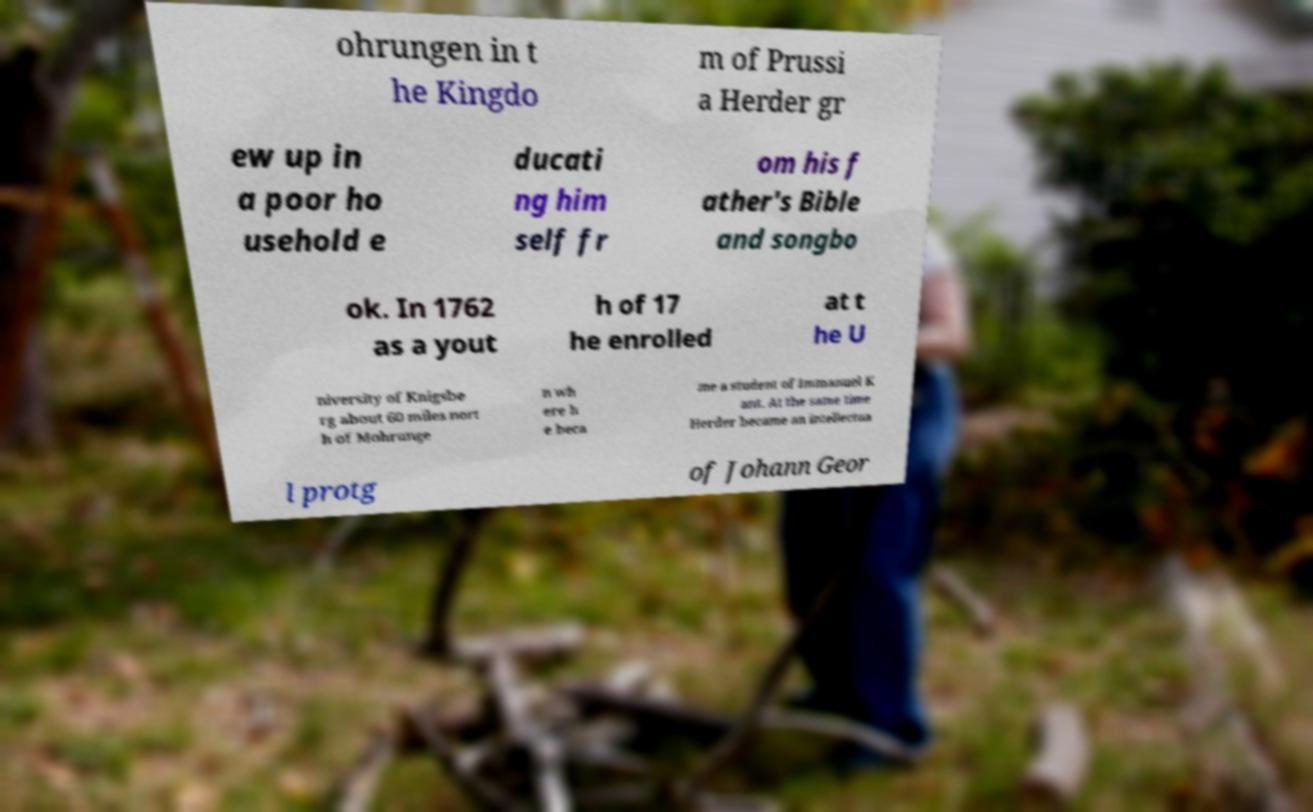Could you extract and type out the text from this image? ohrungen in t he Kingdo m of Prussi a Herder gr ew up in a poor ho usehold e ducati ng him self fr om his f ather's Bible and songbo ok. In 1762 as a yout h of 17 he enrolled at t he U niversity of Knigsbe rg about 60 miles nort h of Mohrunge n wh ere h e beca me a student of Immanuel K ant. At the same time Herder became an intellectua l protg of Johann Geor 